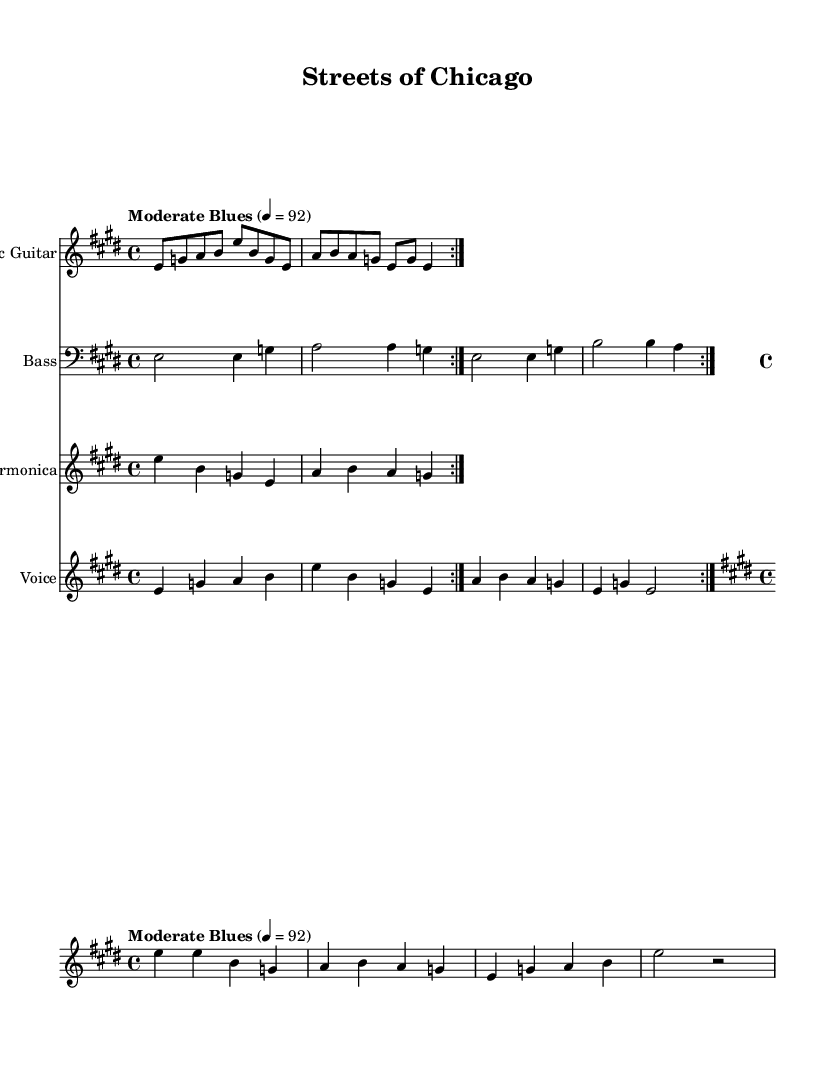What is the key signature of this music? The key signature is E major, which has four sharps (F#, C#, G#, D#) indicated at the beginning of the staff.
Answer: E major What is the time signature of this music? The time signature displayed on the staff is 4/4, meaning there are four beats in each measure and the quarter note gets one beat.
Answer: 4/4 What is the tempo marking for this piece? The tempo marking is "Moderate Blues" and it indicates a tempo of 92 beats per minute, suggesting a moderate pace suitable for a blues style.
Answer: Moderate Blues, 92 In the verse, how many measures are there before the chorus? The verse is structured with four measures, as indicated by the repeated pattern shown before transitioning into the chorus.
Answer: 4 What instruments are included in the score? The instruments listed in the score include Electric Guitar, Bass, Harmonica, and Voice, each having its own staff for musical notation.
Answer: Electric Guitar, Bass, Harmonica, Voice How many times is the verse repeated? The verse is indicated to be repeated twice as noted by the repeat sign (volta) at the beginning of the verse section.
Answer: 2 What social issue is highlighted in the lyrics of this piece? The lyrics mention "Poverty", indicating that social struggles and inequalities in urban life are a central theme of the song.
Answer: Poverty 